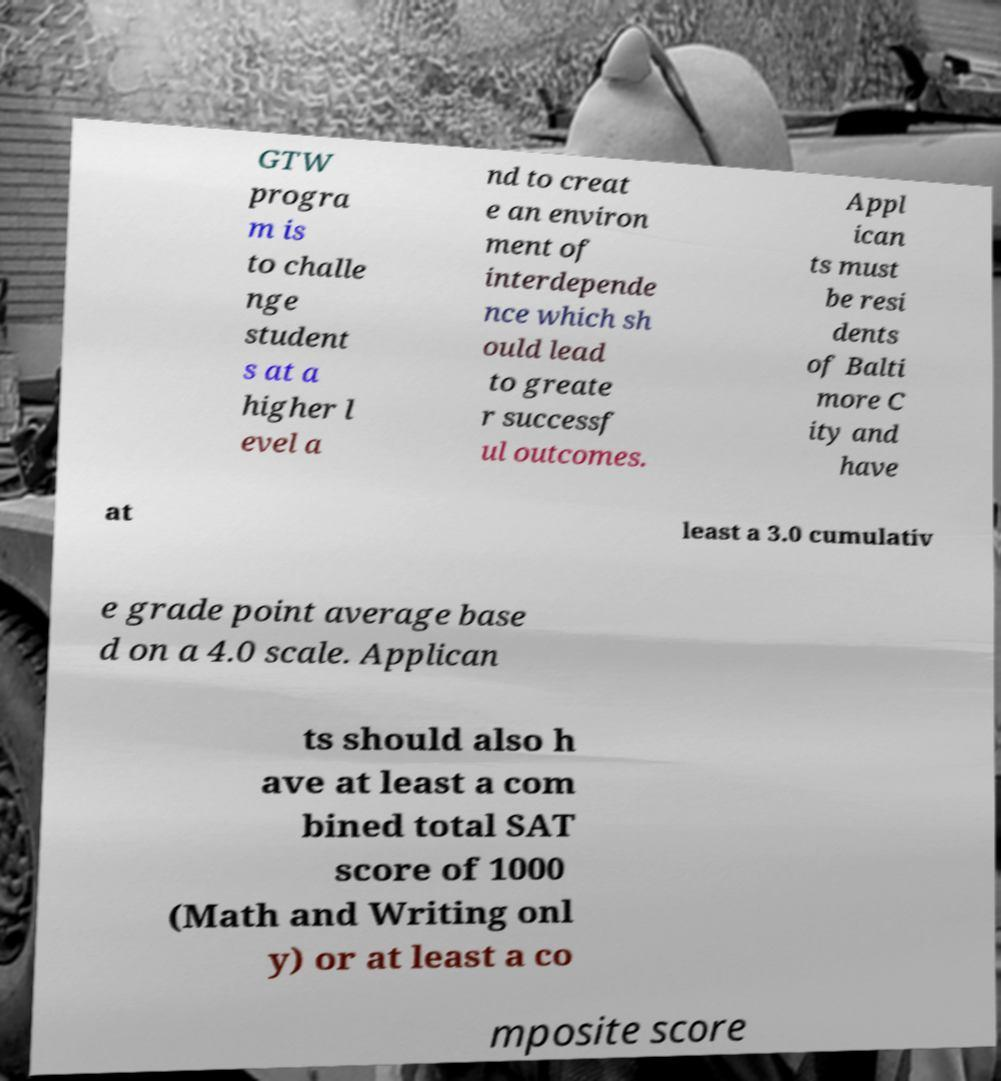Could you assist in decoding the text presented in this image and type it out clearly? GTW progra m is to challe nge student s at a higher l evel a nd to creat e an environ ment of interdepende nce which sh ould lead to greate r successf ul outcomes. Appl ican ts must be resi dents of Balti more C ity and have at least a 3.0 cumulativ e grade point average base d on a 4.0 scale. Applican ts should also h ave at least a com bined total SAT score of 1000 (Math and Writing onl y) or at least a co mposite score 